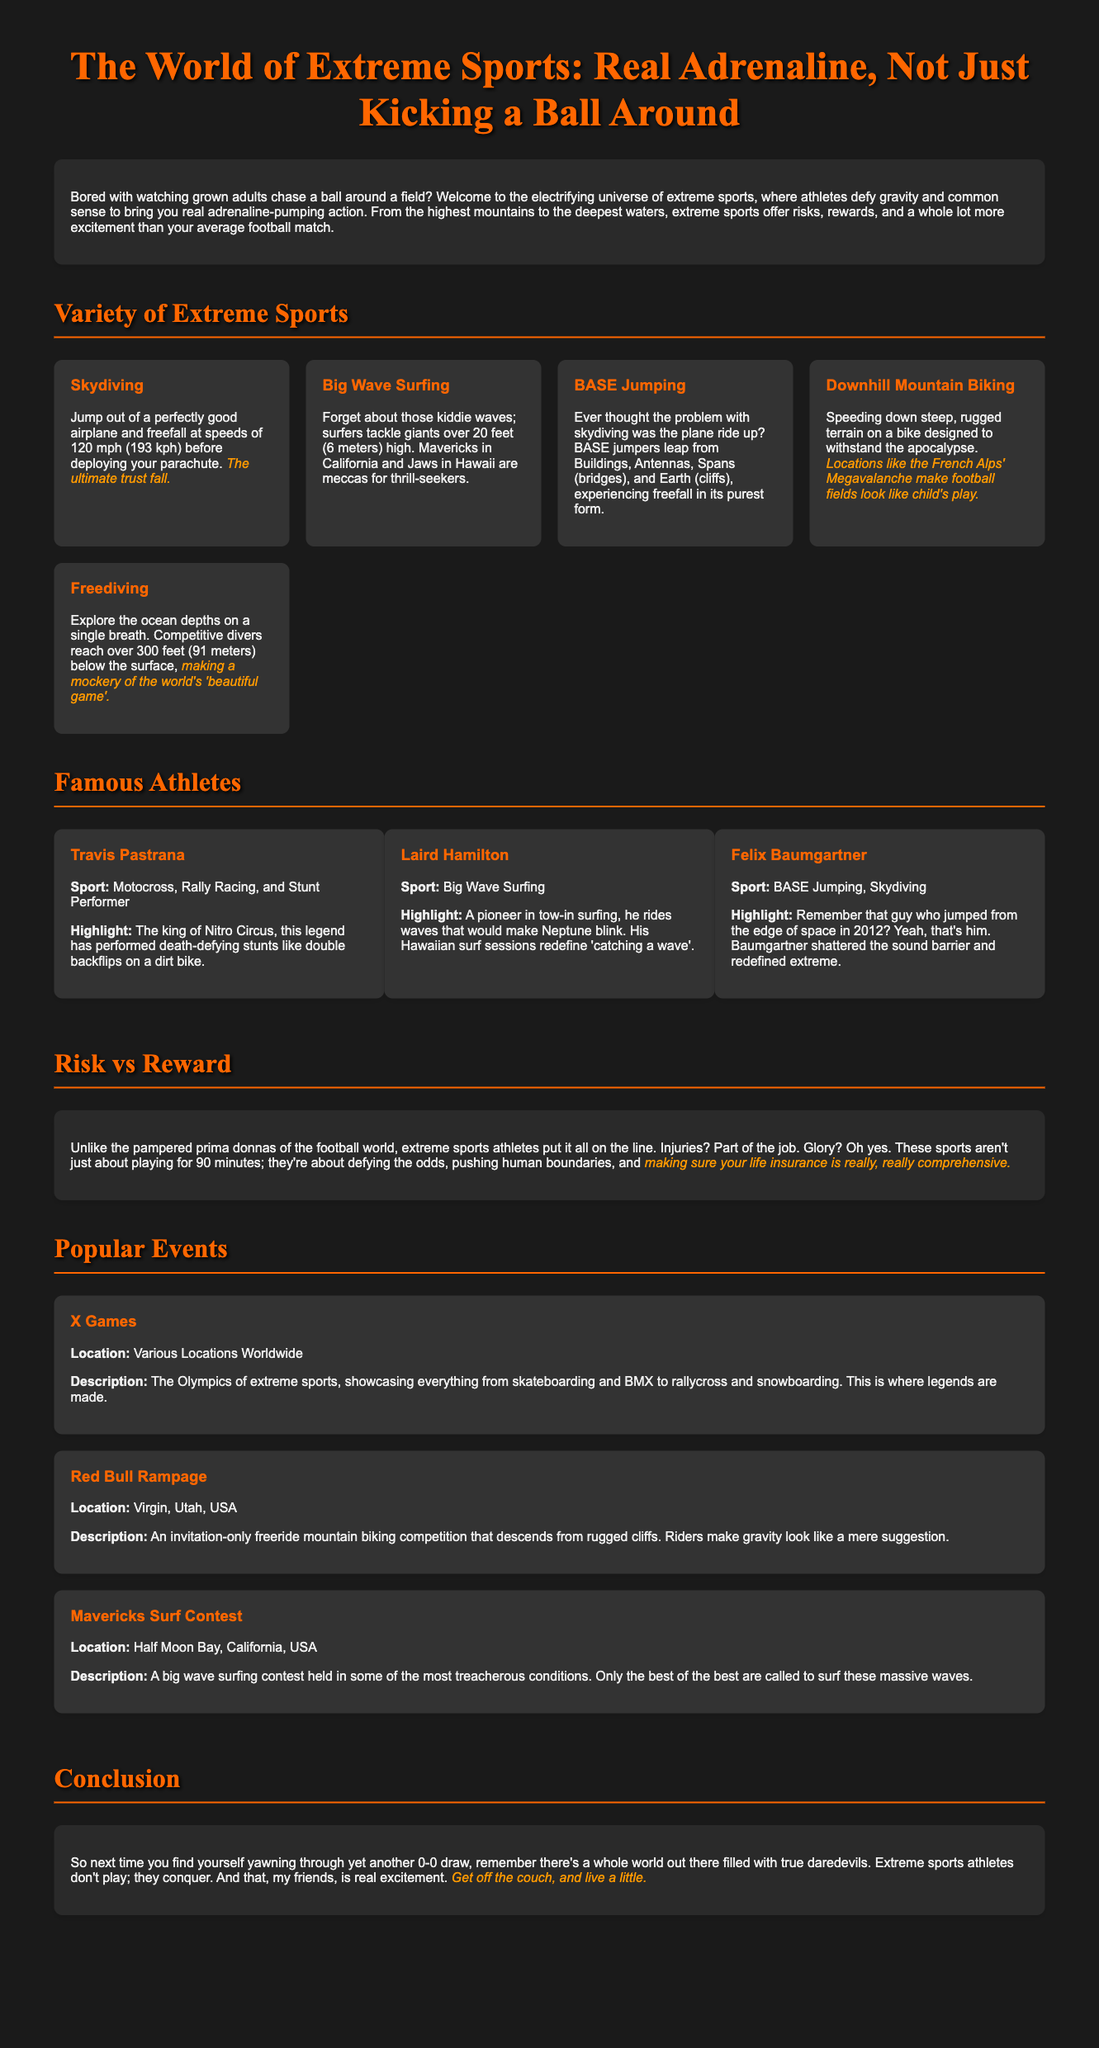what is the title of the infographic? The title is given at the top of the document, emphasizing the comparison with football.
Answer: The World of Extreme Sports: Real Adrenaline, Not Just Kicking a Ball Around how fast do skydivers freefall? The speed of freefall is stated in the description of skydiving, highlighting the thrill.
Answer: 120 mph which extreme sport involves jumping from buildings? The document describes BASE jumping, specifying its unique features.
Answer: BASE Jumping what is the highlight of Felix Baumgartner’s career? The highlight mentions his record-breaking jump from the edge of space in 2012.
Answer: Jumped from the edge of space where is the Red Bull Rampage held? The location of this event is listed in the event section, referencing its unique venue.
Answer: Virgin, Utah, USA what is the main purpose of extreme sports athletes according to the document? The document emphasizes their role in pushing human boundaries and taking risks.
Answer: Defying the odds how many famous athletes are mentioned in the document? The document lists specific athletes as examples of those who participate in extreme sports.
Answer: Three which event is referred to as the "Olympics of extreme sports"? The X Games is described as the most significant competition in extreme sports.
Answer: X Games what is the main message of the conclusion? The conclusion encourages readers to engage with extreme sports over conventional sports.
Answer: Conquer 